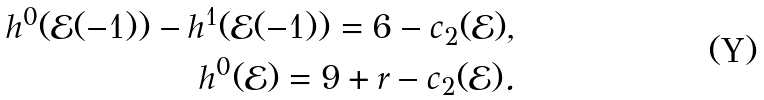<formula> <loc_0><loc_0><loc_500><loc_500>h ^ { 0 } ( \mathcal { E } ( - 1 ) ) - h ^ { 1 } ( \mathcal { E } ( - 1 ) ) = 6 - c _ { 2 } ( \mathcal { E } ) , \\ h ^ { 0 } ( \mathcal { E } ) = 9 + r - c _ { 2 } ( \mathcal { E } ) .</formula> 